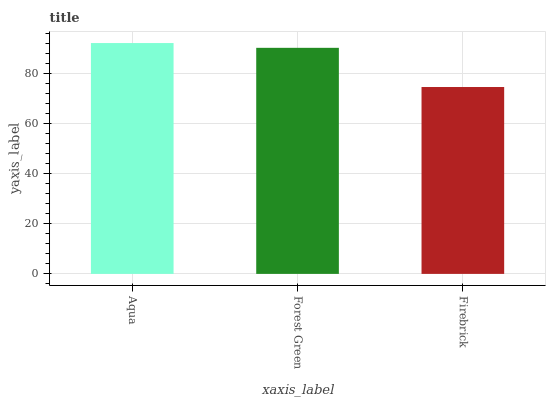Is Forest Green the minimum?
Answer yes or no. No. Is Forest Green the maximum?
Answer yes or no. No. Is Aqua greater than Forest Green?
Answer yes or no. Yes. Is Forest Green less than Aqua?
Answer yes or no. Yes. Is Forest Green greater than Aqua?
Answer yes or no. No. Is Aqua less than Forest Green?
Answer yes or no. No. Is Forest Green the high median?
Answer yes or no. Yes. Is Forest Green the low median?
Answer yes or no. Yes. Is Aqua the high median?
Answer yes or no. No. Is Aqua the low median?
Answer yes or no. No. 